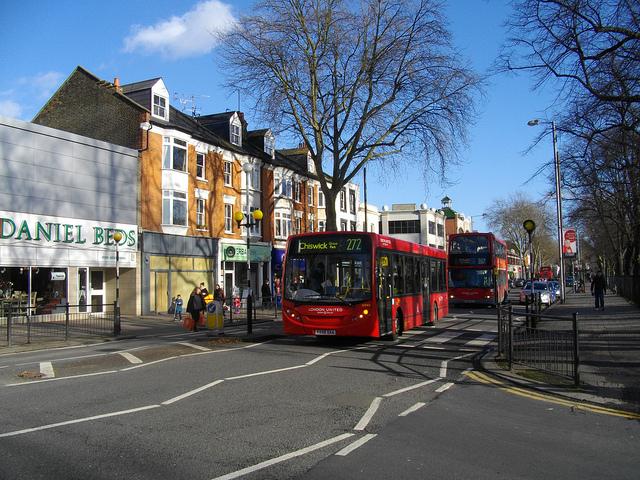What color are the globes on the street lamps?
Be succinct. Yellow. Are all buses double-deckers?
Write a very short answer. No. What kind of weather it is?
Write a very short answer. Sunny. What number is on the lead bus?
Write a very short answer. 272. Is there a person waiting to cross the road?
Be succinct. Yes. 